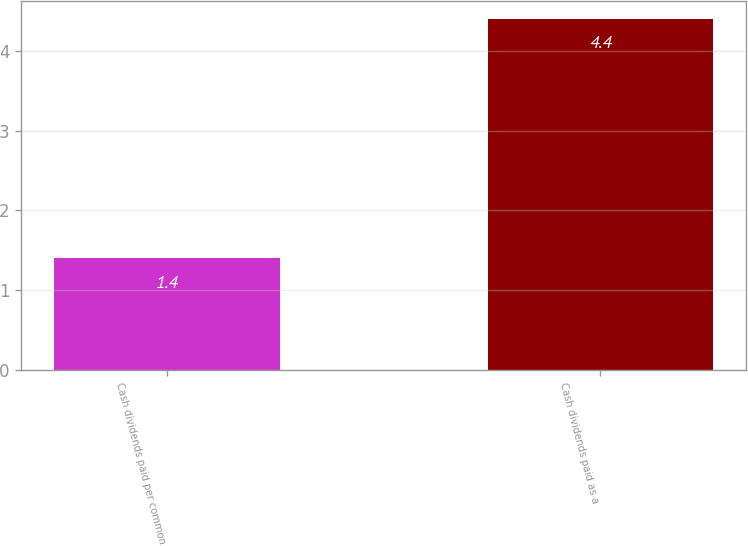Convert chart to OTSL. <chart><loc_0><loc_0><loc_500><loc_500><bar_chart><fcel>Cash dividends paid per common<fcel>Cash dividends paid as a<nl><fcel>1.4<fcel>4.4<nl></chart> 